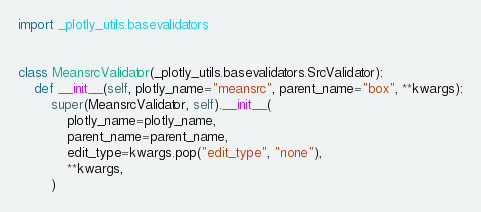<code> <loc_0><loc_0><loc_500><loc_500><_Python_>import _plotly_utils.basevalidators


class MeansrcValidator(_plotly_utils.basevalidators.SrcValidator):
    def __init__(self, plotly_name="meansrc", parent_name="box", **kwargs):
        super(MeansrcValidator, self).__init__(
            plotly_name=plotly_name,
            parent_name=parent_name,
            edit_type=kwargs.pop("edit_type", "none"),
            **kwargs,
        )
</code> 